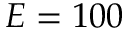Convert formula to latex. <formula><loc_0><loc_0><loc_500><loc_500>E = 1 0 0</formula> 